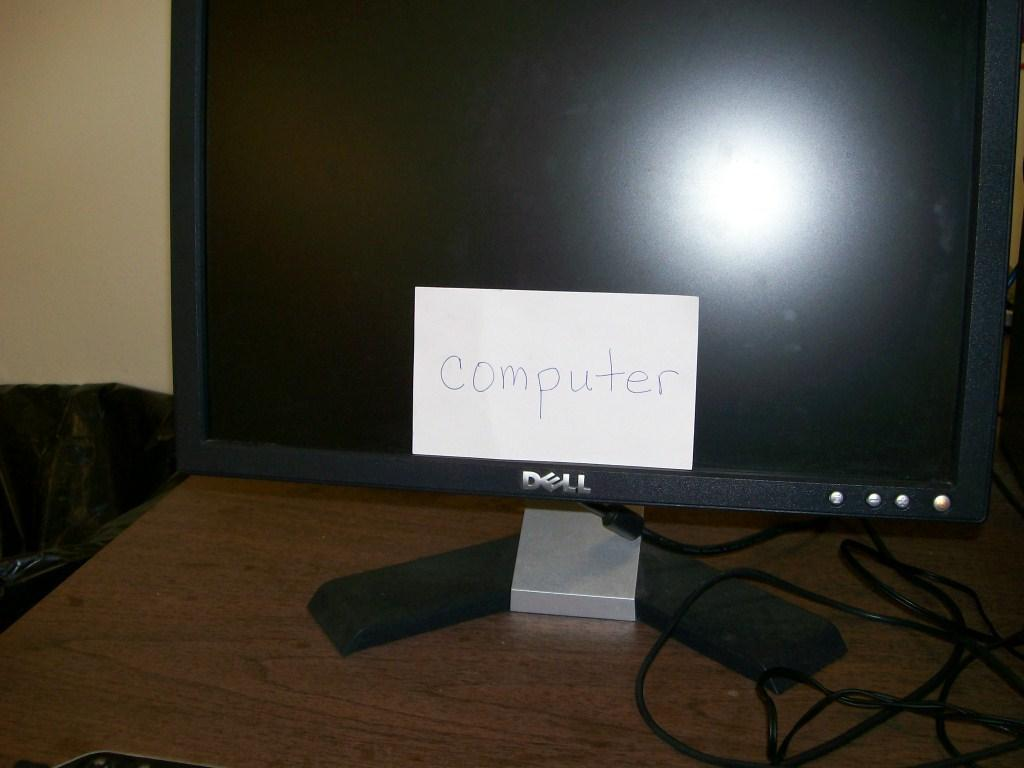<image>
Summarize the visual content of the image. A Dell computer has a note card affixed to the bottom of the monitor reading computer. 